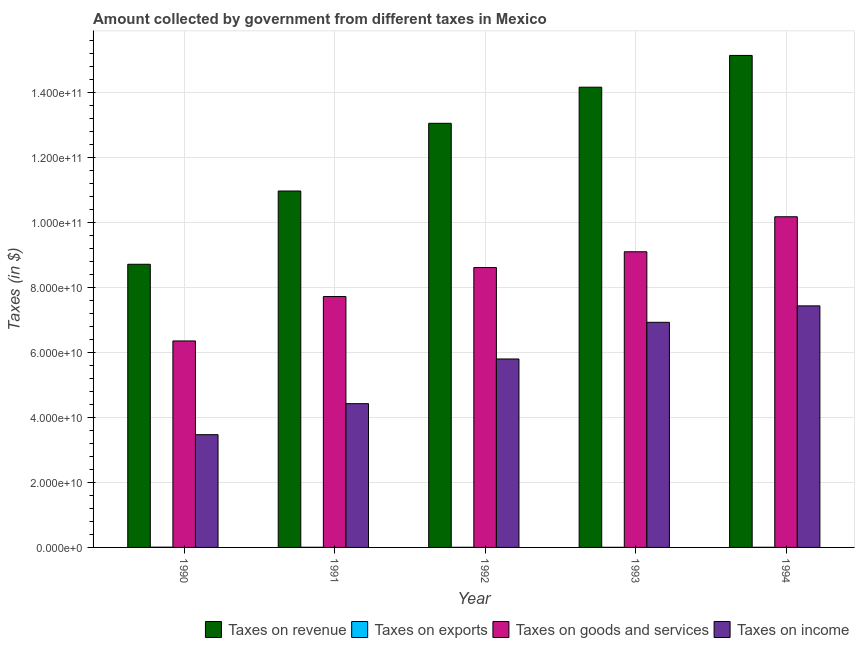How many bars are there on the 1st tick from the left?
Make the answer very short. 4. What is the label of the 4th group of bars from the left?
Give a very brief answer. 1993. What is the amount collected as tax on goods in 1992?
Make the answer very short. 8.61e+1. Across all years, what is the maximum amount collected as tax on exports?
Provide a succinct answer. 7.50e+07. Across all years, what is the minimum amount collected as tax on goods?
Your answer should be very brief. 6.35e+1. What is the total amount collected as tax on revenue in the graph?
Give a very brief answer. 6.20e+11. What is the difference between the amount collected as tax on goods in 1991 and that in 1994?
Offer a very short reply. -2.45e+1. What is the difference between the amount collected as tax on goods in 1993 and the amount collected as tax on revenue in 1990?
Keep it short and to the point. 2.74e+1. What is the average amount collected as tax on revenue per year?
Your answer should be very brief. 1.24e+11. In the year 1991, what is the difference between the amount collected as tax on goods and amount collected as tax on income?
Offer a terse response. 0. What is the ratio of the amount collected as tax on goods in 1991 to that in 1994?
Your answer should be compact. 0.76. Is the difference between the amount collected as tax on exports in 1990 and 1991 greater than the difference between the amount collected as tax on revenue in 1990 and 1991?
Provide a short and direct response. No. What is the difference between the highest and the second highest amount collected as tax on exports?
Keep it short and to the point. 3.40e+07. What is the difference between the highest and the lowest amount collected as tax on goods?
Give a very brief answer. 3.82e+1. In how many years, is the amount collected as tax on revenue greater than the average amount collected as tax on revenue taken over all years?
Keep it short and to the point. 3. Is the sum of the amount collected as tax on income in 1990 and 1994 greater than the maximum amount collected as tax on revenue across all years?
Provide a succinct answer. Yes. What does the 1st bar from the left in 1992 represents?
Provide a short and direct response. Taxes on revenue. What does the 1st bar from the right in 1991 represents?
Ensure brevity in your answer.  Taxes on income. Is it the case that in every year, the sum of the amount collected as tax on revenue and amount collected as tax on exports is greater than the amount collected as tax on goods?
Ensure brevity in your answer.  Yes. How many years are there in the graph?
Your answer should be very brief. 5. What is the difference between two consecutive major ticks on the Y-axis?
Offer a terse response. 2.00e+1. Are the values on the major ticks of Y-axis written in scientific E-notation?
Your response must be concise. Yes. Does the graph contain grids?
Your response must be concise. Yes. How many legend labels are there?
Offer a terse response. 4. How are the legend labels stacked?
Your answer should be very brief. Horizontal. What is the title of the graph?
Your answer should be compact. Amount collected by government from different taxes in Mexico. What is the label or title of the Y-axis?
Your response must be concise. Taxes (in $). What is the Taxes (in $) of Taxes on revenue in 1990?
Give a very brief answer. 8.71e+1. What is the Taxes (in $) in Taxes on exports in 1990?
Offer a terse response. 7.50e+07. What is the Taxes (in $) in Taxes on goods and services in 1990?
Offer a very short reply. 6.35e+1. What is the Taxes (in $) of Taxes on income in 1990?
Keep it short and to the point. 3.47e+1. What is the Taxes (in $) in Taxes on revenue in 1991?
Provide a short and direct response. 1.10e+11. What is the Taxes (in $) of Taxes on exports in 1991?
Provide a short and direct response. 4.10e+07. What is the Taxes (in $) in Taxes on goods and services in 1991?
Your answer should be compact. 7.71e+1. What is the Taxes (in $) in Taxes on income in 1991?
Your answer should be very brief. 4.42e+1. What is the Taxes (in $) of Taxes on revenue in 1992?
Offer a terse response. 1.30e+11. What is the Taxes (in $) of Taxes on exports in 1992?
Provide a short and direct response. 3.80e+07. What is the Taxes (in $) of Taxes on goods and services in 1992?
Ensure brevity in your answer.  8.61e+1. What is the Taxes (in $) of Taxes on income in 1992?
Your answer should be very brief. 5.79e+1. What is the Taxes (in $) in Taxes on revenue in 1993?
Your answer should be very brief. 1.42e+11. What is the Taxes (in $) of Taxes on exports in 1993?
Offer a very short reply. 3.10e+07. What is the Taxes (in $) in Taxes on goods and services in 1993?
Your answer should be compact. 9.09e+1. What is the Taxes (in $) of Taxes on income in 1993?
Your answer should be compact. 6.92e+1. What is the Taxes (in $) in Taxes on revenue in 1994?
Ensure brevity in your answer.  1.51e+11. What is the Taxes (in $) of Taxes on exports in 1994?
Provide a short and direct response. 4.00e+07. What is the Taxes (in $) of Taxes on goods and services in 1994?
Provide a succinct answer. 1.02e+11. What is the Taxes (in $) in Taxes on income in 1994?
Provide a succinct answer. 7.43e+1. Across all years, what is the maximum Taxes (in $) in Taxes on revenue?
Ensure brevity in your answer.  1.51e+11. Across all years, what is the maximum Taxes (in $) of Taxes on exports?
Offer a terse response. 7.50e+07. Across all years, what is the maximum Taxes (in $) of Taxes on goods and services?
Give a very brief answer. 1.02e+11. Across all years, what is the maximum Taxes (in $) in Taxes on income?
Make the answer very short. 7.43e+1. Across all years, what is the minimum Taxes (in $) in Taxes on revenue?
Keep it short and to the point. 8.71e+1. Across all years, what is the minimum Taxes (in $) of Taxes on exports?
Provide a short and direct response. 3.10e+07. Across all years, what is the minimum Taxes (in $) in Taxes on goods and services?
Make the answer very short. 6.35e+1. Across all years, what is the minimum Taxes (in $) of Taxes on income?
Offer a very short reply. 3.47e+1. What is the total Taxes (in $) in Taxes on revenue in the graph?
Give a very brief answer. 6.20e+11. What is the total Taxes (in $) of Taxes on exports in the graph?
Ensure brevity in your answer.  2.25e+08. What is the total Taxes (in $) in Taxes on goods and services in the graph?
Provide a short and direct response. 4.19e+11. What is the total Taxes (in $) in Taxes on income in the graph?
Keep it short and to the point. 2.80e+11. What is the difference between the Taxes (in $) of Taxes on revenue in 1990 and that in 1991?
Your answer should be very brief. -2.25e+1. What is the difference between the Taxes (in $) in Taxes on exports in 1990 and that in 1991?
Your answer should be compact. 3.40e+07. What is the difference between the Taxes (in $) in Taxes on goods and services in 1990 and that in 1991?
Your response must be concise. -1.37e+1. What is the difference between the Taxes (in $) in Taxes on income in 1990 and that in 1991?
Your answer should be compact. -9.54e+09. What is the difference between the Taxes (in $) of Taxes on revenue in 1990 and that in 1992?
Your answer should be very brief. -4.33e+1. What is the difference between the Taxes (in $) of Taxes on exports in 1990 and that in 1992?
Ensure brevity in your answer.  3.70e+07. What is the difference between the Taxes (in $) of Taxes on goods and services in 1990 and that in 1992?
Provide a short and direct response. -2.26e+1. What is the difference between the Taxes (in $) in Taxes on income in 1990 and that in 1992?
Your response must be concise. -2.33e+1. What is the difference between the Taxes (in $) of Taxes on revenue in 1990 and that in 1993?
Provide a short and direct response. -5.44e+1. What is the difference between the Taxes (in $) of Taxes on exports in 1990 and that in 1993?
Your answer should be compact. 4.40e+07. What is the difference between the Taxes (in $) of Taxes on goods and services in 1990 and that in 1993?
Your response must be concise. -2.74e+1. What is the difference between the Taxes (in $) in Taxes on income in 1990 and that in 1993?
Keep it short and to the point. -3.46e+1. What is the difference between the Taxes (in $) in Taxes on revenue in 1990 and that in 1994?
Make the answer very short. -6.42e+1. What is the difference between the Taxes (in $) in Taxes on exports in 1990 and that in 1994?
Offer a terse response. 3.50e+07. What is the difference between the Taxes (in $) in Taxes on goods and services in 1990 and that in 1994?
Ensure brevity in your answer.  -3.82e+1. What is the difference between the Taxes (in $) of Taxes on income in 1990 and that in 1994?
Ensure brevity in your answer.  -3.96e+1. What is the difference between the Taxes (in $) in Taxes on revenue in 1991 and that in 1992?
Offer a terse response. -2.08e+1. What is the difference between the Taxes (in $) of Taxes on exports in 1991 and that in 1992?
Make the answer very short. 3.00e+06. What is the difference between the Taxes (in $) of Taxes on goods and services in 1991 and that in 1992?
Ensure brevity in your answer.  -8.92e+09. What is the difference between the Taxes (in $) in Taxes on income in 1991 and that in 1992?
Your response must be concise. -1.37e+1. What is the difference between the Taxes (in $) of Taxes on revenue in 1991 and that in 1993?
Provide a succinct answer. -3.19e+1. What is the difference between the Taxes (in $) in Taxes on exports in 1991 and that in 1993?
Provide a short and direct response. 1.00e+07. What is the difference between the Taxes (in $) in Taxes on goods and services in 1991 and that in 1993?
Make the answer very short. -1.38e+1. What is the difference between the Taxes (in $) of Taxes on income in 1991 and that in 1993?
Your response must be concise. -2.50e+1. What is the difference between the Taxes (in $) in Taxes on revenue in 1991 and that in 1994?
Provide a succinct answer. -4.17e+1. What is the difference between the Taxes (in $) of Taxes on exports in 1991 and that in 1994?
Keep it short and to the point. 1.00e+06. What is the difference between the Taxes (in $) of Taxes on goods and services in 1991 and that in 1994?
Your response must be concise. -2.45e+1. What is the difference between the Taxes (in $) in Taxes on income in 1991 and that in 1994?
Ensure brevity in your answer.  -3.01e+1. What is the difference between the Taxes (in $) in Taxes on revenue in 1992 and that in 1993?
Offer a very short reply. -1.11e+1. What is the difference between the Taxes (in $) of Taxes on goods and services in 1992 and that in 1993?
Provide a succinct answer. -4.85e+09. What is the difference between the Taxes (in $) of Taxes on income in 1992 and that in 1993?
Offer a very short reply. -1.13e+1. What is the difference between the Taxes (in $) in Taxes on revenue in 1992 and that in 1994?
Make the answer very short. -2.09e+1. What is the difference between the Taxes (in $) in Taxes on goods and services in 1992 and that in 1994?
Offer a terse response. -1.56e+1. What is the difference between the Taxes (in $) of Taxes on income in 1992 and that in 1994?
Your answer should be compact. -1.63e+1. What is the difference between the Taxes (in $) in Taxes on revenue in 1993 and that in 1994?
Ensure brevity in your answer.  -9.77e+09. What is the difference between the Taxes (in $) of Taxes on exports in 1993 and that in 1994?
Offer a terse response. -9.00e+06. What is the difference between the Taxes (in $) of Taxes on goods and services in 1993 and that in 1994?
Offer a very short reply. -1.08e+1. What is the difference between the Taxes (in $) of Taxes on income in 1993 and that in 1994?
Offer a terse response. -5.05e+09. What is the difference between the Taxes (in $) of Taxes on revenue in 1990 and the Taxes (in $) of Taxes on exports in 1991?
Your answer should be very brief. 8.70e+1. What is the difference between the Taxes (in $) in Taxes on revenue in 1990 and the Taxes (in $) in Taxes on goods and services in 1991?
Your response must be concise. 9.92e+09. What is the difference between the Taxes (in $) of Taxes on revenue in 1990 and the Taxes (in $) of Taxes on income in 1991?
Keep it short and to the point. 4.29e+1. What is the difference between the Taxes (in $) in Taxes on exports in 1990 and the Taxes (in $) in Taxes on goods and services in 1991?
Your answer should be compact. -7.71e+1. What is the difference between the Taxes (in $) in Taxes on exports in 1990 and the Taxes (in $) in Taxes on income in 1991?
Your answer should be compact. -4.41e+1. What is the difference between the Taxes (in $) of Taxes on goods and services in 1990 and the Taxes (in $) of Taxes on income in 1991?
Your answer should be compact. 1.93e+1. What is the difference between the Taxes (in $) in Taxes on revenue in 1990 and the Taxes (in $) in Taxes on exports in 1992?
Offer a terse response. 8.70e+1. What is the difference between the Taxes (in $) in Taxes on revenue in 1990 and the Taxes (in $) in Taxes on goods and services in 1992?
Offer a very short reply. 1.00e+09. What is the difference between the Taxes (in $) of Taxes on revenue in 1990 and the Taxes (in $) of Taxes on income in 1992?
Provide a succinct answer. 2.91e+1. What is the difference between the Taxes (in $) of Taxes on exports in 1990 and the Taxes (in $) of Taxes on goods and services in 1992?
Provide a succinct answer. -8.60e+1. What is the difference between the Taxes (in $) of Taxes on exports in 1990 and the Taxes (in $) of Taxes on income in 1992?
Provide a short and direct response. -5.79e+1. What is the difference between the Taxes (in $) of Taxes on goods and services in 1990 and the Taxes (in $) of Taxes on income in 1992?
Offer a terse response. 5.54e+09. What is the difference between the Taxes (in $) of Taxes on revenue in 1990 and the Taxes (in $) of Taxes on exports in 1993?
Offer a very short reply. 8.70e+1. What is the difference between the Taxes (in $) of Taxes on revenue in 1990 and the Taxes (in $) of Taxes on goods and services in 1993?
Offer a terse response. -3.84e+09. What is the difference between the Taxes (in $) in Taxes on revenue in 1990 and the Taxes (in $) in Taxes on income in 1993?
Make the answer very short. 1.78e+1. What is the difference between the Taxes (in $) in Taxes on exports in 1990 and the Taxes (in $) in Taxes on goods and services in 1993?
Give a very brief answer. -9.08e+1. What is the difference between the Taxes (in $) of Taxes on exports in 1990 and the Taxes (in $) of Taxes on income in 1993?
Your answer should be very brief. -6.91e+1. What is the difference between the Taxes (in $) in Taxes on goods and services in 1990 and the Taxes (in $) in Taxes on income in 1993?
Provide a short and direct response. -5.74e+09. What is the difference between the Taxes (in $) of Taxes on revenue in 1990 and the Taxes (in $) of Taxes on exports in 1994?
Provide a short and direct response. 8.70e+1. What is the difference between the Taxes (in $) in Taxes on revenue in 1990 and the Taxes (in $) in Taxes on goods and services in 1994?
Offer a very short reply. -1.46e+1. What is the difference between the Taxes (in $) of Taxes on revenue in 1990 and the Taxes (in $) of Taxes on income in 1994?
Provide a succinct answer. 1.28e+1. What is the difference between the Taxes (in $) of Taxes on exports in 1990 and the Taxes (in $) of Taxes on goods and services in 1994?
Offer a very short reply. -1.02e+11. What is the difference between the Taxes (in $) of Taxes on exports in 1990 and the Taxes (in $) of Taxes on income in 1994?
Keep it short and to the point. -7.42e+1. What is the difference between the Taxes (in $) of Taxes on goods and services in 1990 and the Taxes (in $) of Taxes on income in 1994?
Offer a very short reply. -1.08e+1. What is the difference between the Taxes (in $) in Taxes on revenue in 1991 and the Taxes (in $) in Taxes on exports in 1992?
Your response must be concise. 1.10e+11. What is the difference between the Taxes (in $) of Taxes on revenue in 1991 and the Taxes (in $) of Taxes on goods and services in 1992?
Your response must be concise. 2.35e+1. What is the difference between the Taxes (in $) of Taxes on revenue in 1991 and the Taxes (in $) of Taxes on income in 1992?
Keep it short and to the point. 5.16e+1. What is the difference between the Taxes (in $) in Taxes on exports in 1991 and the Taxes (in $) in Taxes on goods and services in 1992?
Offer a very short reply. -8.60e+1. What is the difference between the Taxes (in $) in Taxes on exports in 1991 and the Taxes (in $) in Taxes on income in 1992?
Offer a very short reply. -5.79e+1. What is the difference between the Taxes (in $) of Taxes on goods and services in 1991 and the Taxes (in $) of Taxes on income in 1992?
Give a very brief answer. 1.92e+1. What is the difference between the Taxes (in $) in Taxes on revenue in 1991 and the Taxes (in $) in Taxes on exports in 1993?
Give a very brief answer. 1.10e+11. What is the difference between the Taxes (in $) of Taxes on revenue in 1991 and the Taxes (in $) of Taxes on goods and services in 1993?
Give a very brief answer. 1.87e+1. What is the difference between the Taxes (in $) of Taxes on revenue in 1991 and the Taxes (in $) of Taxes on income in 1993?
Make the answer very short. 4.04e+1. What is the difference between the Taxes (in $) in Taxes on exports in 1991 and the Taxes (in $) in Taxes on goods and services in 1993?
Make the answer very short. -9.09e+1. What is the difference between the Taxes (in $) of Taxes on exports in 1991 and the Taxes (in $) of Taxes on income in 1993?
Provide a short and direct response. -6.92e+1. What is the difference between the Taxes (in $) in Taxes on goods and services in 1991 and the Taxes (in $) in Taxes on income in 1993?
Provide a succinct answer. 7.92e+09. What is the difference between the Taxes (in $) in Taxes on revenue in 1991 and the Taxes (in $) in Taxes on exports in 1994?
Your response must be concise. 1.10e+11. What is the difference between the Taxes (in $) in Taxes on revenue in 1991 and the Taxes (in $) in Taxes on goods and services in 1994?
Provide a succinct answer. 7.92e+09. What is the difference between the Taxes (in $) of Taxes on revenue in 1991 and the Taxes (in $) of Taxes on income in 1994?
Make the answer very short. 3.53e+1. What is the difference between the Taxes (in $) in Taxes on exports in 1991 and the Taxes (in $) in Taxes on goods and services in 1994?
Provide a succinct answer. -1.02e+11. What is the difference between the Taxes (in $) in Taxes on exports in 1991 and the Taxes (in $) in Taxes on income in 1994?
Your answer should be compact. -7.42e+1. What is the difference between the Taxes (in $) of Taxes on goods and services in 1991 and the Taxes (in $) of Taxes on income in 1994?
Your answer should be very brief. 2.87e+09. What is the difference between the Taxes (in $) of Taxes on revenue in 1992 and the Taxes (in $) of Taxes on exports in 1993?
Offer a very short reply. 1.30e+11. What is the difference between the Taxes (in $) of Taxes on revenue in 1992 and the Taxes (in $) of Taxes on goods and services in 1993?
Provide a short and direct response. 3.95e+1. What is the difference between the Taxes (in $) of Taxes on revenue in 1992 and the Taxes (in $) of Taxes on income in 1993?
Offer a very short reply. 6.12e+1. What is the difference between the Taxes (in $) in Taxes on exports in 1992 and the Taxes (in $) in Taxes on goods and services in 1993?
Your answer should be very brief. -9.09e+1. What is the difference between the Taxes (in $) in Taxes on exports in 1992 and the Taxes (in $) in Taxes on income in 1993?
Your response must be concise. -6.92e+1. What is the difference between the Taxes (in $) of Taxes on goods and services in 1992 and the Taxes (in $) of Taxes on income in 1993?
Your response must be concise. 1.68e+1. What is the difference between the Taxes (in $) in Taxes on revenue in 1992 and the Taxes (in $) in Taxes on exports in 1994?
Give a very brief answer. 1.30e+11. What is the difference between the Taxes (in $) in Taxes on revenue in 1992 and the Taxes (in $) in Taxes on goods and services in 1994?
Offer a terse response. 2.87e+1. What is the difference between the Taxes (in $) in Taxes on revenue in 1992 and the Taxes (in $) in Taxes on income in 1994?
Provide a short and direct response. 5.61e+1. What is the difference between the Taxes (in $) of Taxes on exports in 1992 and the Taxes (in $) of Taxes on goods and services in 1994?
Offer a very short reply. -1.02e+11. What is the difference between the Taxes (in $) in Taxes on exports in 1992 and the Taxes (in $) in Taxes on income in 1994?
Provide a short and direct response. -7.42e+1. What is the difference between the Taxes (in $) of Taxes on goods and services in 1992 and the Taxes (in $) of Taxes on income in 1994?
Make the answer very short. 1.18e+1. What is the difference between the Taxes (in $) in Taxes on revenue in 1993 and the Taxes (in $) in Taxes on exports in 1994?
Give a very brief answer. 1.41e+11. What is the difference between the Taxes (in $) in Taxes on revenue in 1993 and the Taxes (in $) in Taxes on goods and services in 1994?
Make the answer very short. 3.98e+1. What is the difference between the Taxes (in $) of Taxes on revenue in 1993 and the Taxes (in $) of Taxes on income in 1994?
Make the answer very short. 6.72e+1. What is the difference between the Taxes (in $) in Taxes on exports in 1993 and the Taxes (in $) in Taxes on goods and services in 1994?
Give a very brief answer. -1.02e+11. What is the difference between the Taxes (in $) in Taxes on exports in 1993 and the Taxes (in $) in Taxes on income in 1994?
Provide a short and direct response. -7.42e+1. What is the difference between the Taxes (in $) in Taxes on goods and services in 1993 and the Taxes (in $) in Taxes on income in 1994?
Provide a succinct answer. 1.66e+1. What is the average Taxes (in $) in Taxes on revenue per year?
Offer a very short reply. 1.24e+11. What is the average Taxes (in $) of Taxes on exports per year?
Your answer should be very brief. 4.50e+07. What is the average Taxes (in $) in Taxes on goods and services per year?
Keep it short and to the point. 8.39e+1. What is the average Taxes (in $) in Taxes on income per year?
Make the answer very short. 5.61e+1. In the year 1990, what is the difference between the Taxes (in $) in Taxes on revenue and Taxes (in $) in Taxes on exports?
Offer a very short reply. 8.70e+1. In the year 1990, what is the difference between the Taxes (in $) of Taxes on revenue and Taxes (in $) of Taxes on goods and services?
Make the answer very short. 2.36e+1. In the year 1990, what is the difference between the Taxes (in $) in Taxes on revenue and Taxes (in $) in Taxes on income?
Keep it short and to the point. 5.24e+1. In the year 1990, what is the difference between the Taxes (in $) in Taxes on exports and Taxes (in $) in Taxes on goods and services?
Your answer should be very brief. -6.34e+1. In the year 1990, what is the difference between the Taxes (in $) of Taxes on exports and Taxes (in $) of Taxes on income?
Provide a short and direct response. -3.46e+1. In the year 1990, what is the difference between the Taxes (in $) of Taxes on goods and services and Taxes (in $) of Taxes on income?
Your answer should be compact. 2.88e+1. In the year 1991, what is the difference between the Taxes (in $) in Taxes on revenue and Taxes (in $) in Taxes on exports?
Keep it short and to the point. 1.10e+11. In the year 1991, what is the difference between the Taxes (in $) in Taxes on revenue and Taxes (in $) in Taxes on goods and services?
Offer a terse response. 3.24e+1. In the year 1991, what is the difference between the Taxes (in $) of Taxes on revenue and Taxes (in $) of Taxes on income?
Ensure brevity in your answer.  6.54e+1. In the year 1991, what is the difference between the Taxes (in $) of Taxes on exports and Taxes (in $) of Taxes on goods and services?
Ensure brevity in your answer.  -7.71e+1. In the year 1991, what is the difference between the Taxes (in $) in Taxes on exports and Taxes (in $) in Taxes on income?
Keep it short and to the point. -4.42e+1. In the year 1991, what is the difference between the Taxes (in $) of Taxes on goods and services and Taxes (in $) of Taxes on income?
Give a very brief answer. 3.29e+1. In the year 1992, what is the difference between the Taxes (in $) in Taxes on revenue and Taxes (in $) in Taxes on exports?
Provide a short and direct response. 1.30e+11. In the year 1992, what is the difference between the Taxes (in $) of Taxes on revenue and Taxes (in $) of Taxes on goods and services?
Keep it short and to the point. 4.43e+1. In the year 1992, what is the difference between the Taxes (in $) of Taxes on revenue and Taxes (in $) of Taxes on income?
Your answer should be compact. 7.25e+1. In the year 1992, what is the difference between the Taxes (in $) in Taxes on exports and Taxes (in $) in Taxes on goods and services?
Your response must be concise. -8.60e+1. In the year 1992, what is the difference between the Taxes (in $) in Taxes on exports and Taxes (in $) in Taxes on income?
Offer a terse response. -5.79e+1. In the year 1992, what is the difference between the Taxes (in $) in Taxes on goods and services and Taxes (in $) in Taxes on income?
Keep it short and to the point. 2.81e+1. In the year 1993, what is the difference between the Taxes (in $) of Taxes on revenue and Taxes (in $) of Taxes on exports?
Your response must be concise. 1.41e+11. In the year 1993, what is the difference between the Taxes (in $) in Taxes on revenue and Taxes (in $) in Taxes on goods and services?
Ensure brevity in your answer.  5.06e+1. In the year 1993, what is the difference between the Taxes (in $) of Taxes on revenue and Taxes (in $) of Taxes on income?
Offer a very short reply. 7.23e+1. In the year 1993, what is the difference between the Taxes (in $) in Taxes on exports and Taxes (in $) in Taxes on goods and services?
Offer a very short reply. -9.09e+1. In the year 1993, what is the difference between the Taxes (in $) in Taxes on exports and Taxes (in $) in Taxes on income?
Give a very brief answer. -6.92e+1. In the year 1993, what is the difference between the Taxes (in $) of Taxes on goods and services and Taxes (in $) of Taxes on income?
Your answer should be compact. 2.17e+1. In the year 1994, what is the difference between the Taxes (in $) in Taxes on revenue and Taxes (in $) in Taxes on exports?
Offer a very short reply. 1.51e+11. In the year 1994, what is the difference between the Taxes (in $) in Taxes on revenue and Taxes (in $) in Taxes on goods and services?
Keep it short and to the point. 4.96e+1. In the year 1994, what is the difference between the Taxes (in $) of Taxes on revenue and Taxes (in $) of Taxes on income?
Give a very brief answer. 7.70e+1. In the year 1994, what is the difference between the Taxes (in $) in Taxes on exports and Taxes (in $) in Taxes on goods and services?
Give a very brief answer. -1.02e+11. In the year 1994, what is the difference between the Taxes (in $) of Taxes on exports and Taxes (in $) of Taxes on income?
Keep it short and to the point. -7.42e+1. In the year 1994, what is the difference between the Taxes (in $) of Taxes on goods and services and Taxes (in $) of Taxes on income?
Your answer should be very brief. 2.74e+1. What is the ratio of the Taxes (in $) of Taxes on revenue in 1990 to that in 1991?
Keep it short and to the point. 0.79. What is the ratio of the Taxes (in $) in Taxes on exports in 1990 to that in 1991?
Keep it short and to the point. 1.83. What is the ratio of the Taxes (in $) of Taxes on goods and services in 1990 to that in 1991?
Your answer should be compact. 0.82. What is the ratio of the Taxes (in $) of Taxes on income in 1990 to that in 1991?
Keep it short and to the point. 0.78. What is the ratio of the Taxes (in $) in Taxes on revenue in 1990 to that in 1992?
Keep it short and to the point. 0.67. What is the ratio of the Taxes (in $) in Taxes on exports in 1990 to that in 1992?
Keep it short and to the point. 1.97. What is the ratio of the Taxes (in $) in Taxes on goods and services in 1990 to that in 1992?
Your answer should be very brief. 0.74. What is the ratio of the Taxes (in $) in Taxes on income in 1990 to that in 1992?
Your answer should be very brief. 0.6. What is the ratio of the Taxes (in $) of Taxes on revenue in 1990 to that in 1993?
Keep it short and to the point. 0.62. What is the ratio of the Taxes (in $) of Taxes on exports in 1990 to that in 1993?
Your answer should be very brief. 2.42. What is the ratio of the Taxes (in $) of Taxes on goods and services in 1990 to that in 1993?
Provide a short and direct response. 0.7. What is the ratio of the Taxes (in $) in Taxes on income in 1990 to that in 1993?
Offer a terse response. 0.5. What is the ratio of the Taxes (in $) in Taxes on revenue in 1990 to that in 1994?
Offer a terse response. 0.58. What is the ratio of the Taxes (in $) of Taxes on exports in 1990 to that in 1994?
Provide a short and direct response. 1.88. What is the ratio of the Taxes (in $) of Taxes on goods and services in 1990 to that in 1994?
Keep it short and to the point. 0.62. What is the ratio of the Taxes (in $) of Taxes on income in 1990 to that in 1994?
Offer a terse response. 0.47. What is the ratio of the Taxes (in $) of Taxes on revenue in 1991 to that in 1992?
Give a very brief answer. 0.84. What is the ratio of the Taxes (in $) of Taxes on exports in 1991 to that in 1992?
Give a very brief answer. 1.08. What is the ratio of the Taxes (in $) of Taxes on goods and services in 1991 to that in 1992?
Offer a terse response. 0.9. What is the ratio of the Taxes (in $) in Taxes on income in 1991 to that in 1992?
Provide a succinct answer. 0.76. What is the ratio of the Taxes (in $) in Taxes on revenue in 1991 to that in 1993?
Keep it short and to the point. 0.77. What is the ratio of the Taxes (in $) in Taxes on exports in 1991 to that in 1993?
Your answer should be compact. 1.32. What is the ratio of the Taxes (in $) in Taxes on goods and services in 1991 to that in 1993?
Your answer should be compact. 0.85. What is the ratio of the Taxes (in $) of Taxes on income in 1991 to that in 1993?
Your answer should be very brief. 0.64. What is the ratio of the Taxes (in $) in Taxes on revenue in 1991 to that in 1994?
Your response must be concise. 0.72. What is the ratio of the Taxes (in $) in Taxes on goods and services in 1991 to that in 1994?
Your answer should be compact. 0.76. What is the ratio of the Taxes (in $) in Taxes on income in 1991 to that in 1994?
Offer a very short reply. 0.6. What is the ratio of the Taxes (in $) in Taxes on revenue in 1992 to that in 1993?
Give a very brief answer. 0.92. What is the ratio of the Taxes (in $) in Taxes on exports in 1992 to that in 1993?
Offer a terse response. 1.23. What is the ratio of the Taxes (in $) in Taxes on goods and services in 1992 to that in 1993?
Provide a succinct answer. 0.95. What is the ratio of the Taxes (in $) of Taxes on income in 1992 to that in 1993?
Offer a very short reply. 0.84. What is the ratio of the Taxes (in $) in Taxes on revenue in 1992 to that in 1994?
Offer a very short reply. 0.86. What is the ratio of the Taxes (in $) of Taxes on exports in 1992 to that in 1994?
Your response must be concise. 0.95. What is the ratio of the Taxes (in $) of Taxes on goods and services in 1992 to that in 1994?
Offer a terse response. 0.85. What is the ratio of the Taxes (in $) in Taxes on income in 1992 to that in 1994?
Provide a succinct answer. 0.78. What is the ratio of the Taxes (in $) of Taxes on revenue in 1993 to that in 1994?
Offer a terse response. 0.94. What is the ratio of the Taxes (in $) in Taxes on exports in 1993 to that in 1994?
Provide a succinct answer. 0.78. What is the ratio of the Taxes (in $) of Taxes on goods and services in 1993 to that in 1994?
Keep it short and to the point. 0.89. What is the ratio of the Taxes (in $) in Taxes on income in 1993 to that in 1994?
Your response must be concise. 0.93. What is the difference between the highest and the second highest Taxes (in $) of Taxes on revenue?
Provide a succinct answer. 9.77e+09. What is the difference between the highest and the second highest Taxes (in $) in Taxes on exports?
Ensure brevity in your answer.  3.40e+07. What is the difference between the highest and the second highest Taxes (in $) of Taxes on goods and services?
Provide a short and direct response. 1.08e+1. What is the difference between the highest and the second highest Taxes (in $) in Taxes on income?
Your answer should be compact. 5.05e+09. What is the difference between the highest and the lowest Taxes (in $) of Taxes on revenue?
Your response must be concise. 6.42e+1. What is the difference between the highest and the lowest Taxes (in $) of Taxes on exports?
Your answer should be compact. 4.40e+07. What is the difference between the highest and the lowest Taxes (in $) of Taxes on goods and services?
Give a very brief answer. 3.82e+1. What is the difference between the highest and the lowest Taxes (in $) in Taxes on income?
Keep it short and to the point. 3.96e+1. 